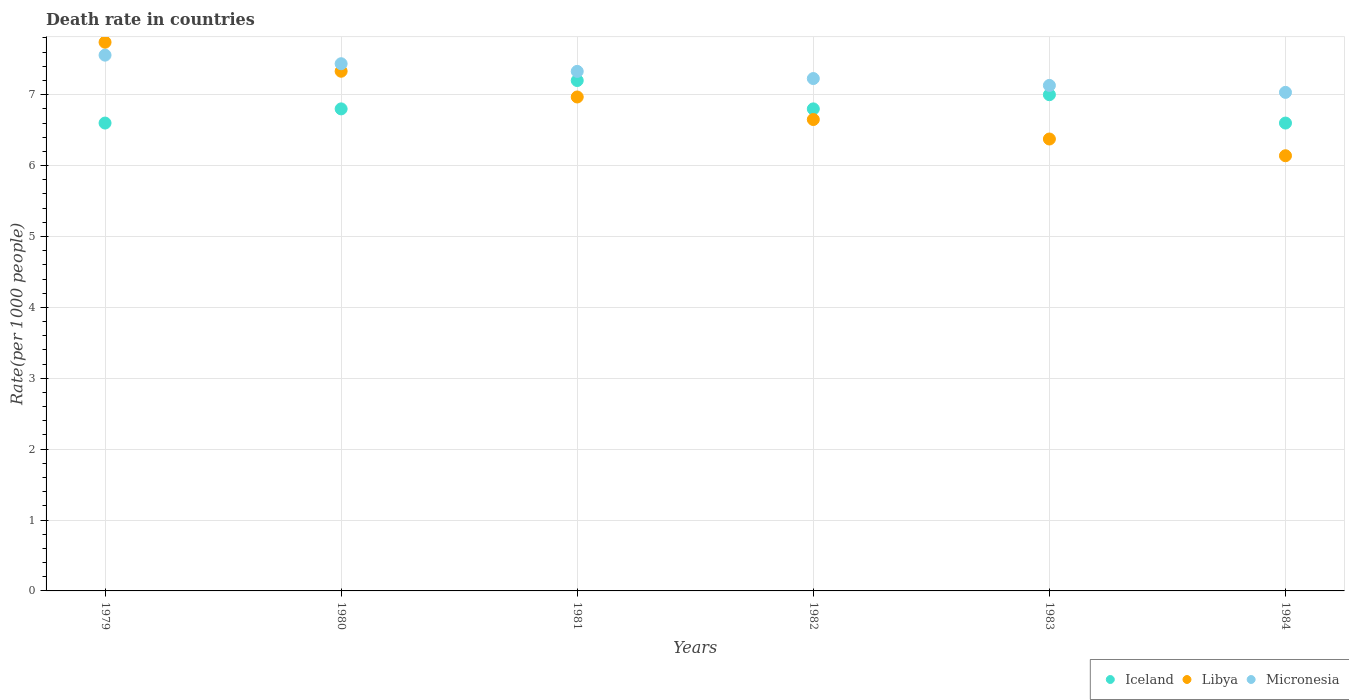How many different coloured dotlines are there?
Your answer should be very brief. 3. Is the number of dotlines equal to the number of legend labels?
Your answer should be very brief. Yes. What is the death rate in Libya in 1983?
Give a very brief answer. 6.38. Across all years, what is the maximum death rate in Libya?
Offer a very short reply. 7.74. Across all years, what is the minimum death rate in Libya?
Offer a very short reply. 6.14. In which year was the death rate in Micronesia maximum?
Your response must be concise. 1979. In which year was the death rate in Iceland minimum?
Make the answer very short. 1979. What is the total death rate in Micronesia in the graph?
Provide a succinct answer. 43.72. What is the difference between the death rate in Libya in 1980 and that in 1984?
Offer a terse response. 1.19. What is the difference between the death rate in Libya in 1983 and the death rate in Micronesia in 1982?
Offer a very short reply. -0.85. What is the average death rate in Micronesia per year?
Provide a succinct answer. 7.29. In the year 1979, what is the difference between the death rate in Micronesia and death rate in Iceland?
Provide a short and direct response. 0.96. In how many years, is the death rate in Libya greater than 1.6?
Give a very brief answer. 6. What is the ratio of the death rate in Iceland in 1981 to that in 1983?
Ensure brevity in your answer.  1.03. Is the death rate in Micronesia in 1980 less than that in 1984?
Provide a short and direct response. No. What is the difference between the highest and the second highest death rate in Libya?
Keep it short and to the point. 0.41. What is the difference between the highest and the lowest death rate in Libya?
Give a very brief answer. 1.6. Is the sum of the death rate in Libya in 1979 and 1983 greater than the maximum death rate in Micronesia across all years?
Ensure brevity in your answer.  Yes. Is it the case that in every year, the sum of the death rate in Micronesia and death rate in Libya  is greater than the death rate in Iceland?
Your answer should be compact. Yes. Does the death rate in Libya monotonically increase over the years?
Your response must be concise. No. Is the death rate in Libya strictly greater than the death rate in Micronesia over the years?
Give a very brief answer. No. Is the death rate in Libya strictly less than the death rate in Micronesia over the years?
Provide a short and direct response. No. Are the values on the major ticks of Y-axis written in scientific E-notation?
Provide a succinct answer. No. Does the graph contain grids?
Provide a short and direct response. Yes. What is the title of the graph?
Keep it short and to the point. Death rate in countries. What is the label or title of the X-axis?
Give a very brief answer. Years. What is the label or title of the Y-axis?
Your response must be concise. Rate(per 1000 people). What is the Rate(per 1000 people) of Libya in 1979?
Offer a very short reply. 7.74. What is the Rate(per 1000 people) in Micronesia in 1979?
Give a very brief answer. 7.56. What is the Rate(per 1000 people) in Iceland in 1980?
Offer a very short reply. 6.8. What is the Rate(per 1000 people) of Libya in 1980?
Make the answer very short. 7.33. What is the Rate(per 1000 people) in Micronesia in 1980?
Your answer should be very brief. 7.44. What is the Rate(per 1000 people) in Libya in 1981?
Provide a succinct answer. 6.97. What is the Rate(per 1000 people) of Micronesia in 1981?
Your response must be concise. 7.33. What is the Rate(per 1000 people) of Libya in 1982?
Provide a succinct answer. 6.65. What is the Rate(per 1000 people) in Micronesia in 1982?
Ensure brevity in your answer.  7.23. What is the Rate(per 1000 people) in Iceland in 1983?
Ensure brevity in your answer.  7. What is the Rate(per 1000 people) of Libya in 1983?
Ensure brevity in your answer.  6.38. What is the Rate(per 1000 people) in Micronesia in 1983?
Keep it short and to the point. 7.13. What is the Rate(per 1000 people) of Libya in 1984?
Your answer should be very brief. 6.14. What is the Rate(per 1000 people) of Micronesia in 1984?
Your response must be concise. 7.03. Across all years, what is the maximum Rate(per 1000 people) of Iceland?
Offer a terse response. 7.2. Across all years, what is the maximum Rate(per 1000 people) in Libya?
Your response must be concise. 7.74. Across all years, what is the maximum Rate(per 1000 people) of Micronesia?
Offer a terse response. 7.56. Across all years, what is the minimum Rate(per 1000 people) in Libya?
Make the answer very short. 6.14. Across all years, what is the minimum Rate(per 1000 people) in Micronesia?
Keep it short and to the point. 7.03. What is the total Rate(per 1000 people) of Libya in the graph?
Give a very brief answer. 41.2. What is the total Rate(per 1000 people) in Micronesia in the graph?
Keep it short and to the point. 43.72. What is the difference between the Rate(per 1000 people) in Libya in 1979 and that in 1980?
Your answer should be compact. 0.41. What is the difference between the Rate(per 1000 people) in Micronesia in 1979 and that in 1980?
Offer a terse response. 0.12. What is the difference between the Rate(per 1000 people) in Iceland in 1979 and that in 1981?
Offer a terse response. -0.6. What is the difference between the Rate(per 1000 people) of Libya in 1979 and that in 1981?
Your response must be concise. 0.77. What is the difference between the Rate(per 1000 people) in Micronesia in 1979 and that in 1981?
Make the answer very short. 0.23. What is the difference between the Rate(per 1000 people) in Libya in 1979 and that in 1982?
Provide a short and direct response. 1.09. What is the difference between the Rate(per 1000 people) of Micronesia in 1979 and that in 1982?
Give a very brief answer. 0.33. What is the difference between the Rate(per 1000 people) in Libya in 1979 and that in 1983?
Offer a very short reply. 1.36. What is the difference between the Rate(per 1000 people) in Micronesia in 1979 and that in 1983?
Ensure brevity in your answer.  0.43. What is the difference between the Rate(per 1000 people) of Libya in 1979 and that in 1984?
Provide a succinct answer. 1.6. What is the difference between the Rate(per 1000 people) of Micronesia in 1979 and that in 1984?
Your answer should be very brief. 0.53. What is the difference between the Rate(per 1000 people) in Iceland in 1980 and that in 1981?
Your answer should be very brief. -0.4. What is the difference between the Rate(per 1000 people) of Libya in 1980 and that in 1981?
Your response must be concise. 0.36. What is the difference between the Rate(per 1000 people) in Micronesia in 1980 and that in 1981?
Make the answer very short. 0.11. What is the difference between the Rate(per 1000 people) of Libya in 1980 and that in 1982?
Offer a very short reply. 0.68. What is the difference between the Rate(per 1000 people) in Micronesia in 1980 and that in 1982?
Ensure brevity in your answer.  0.21. What is the difference between the Rate(per 1000 people) in Libya in 1980 and that in 1983?
Your response must be concise. 0.96. What is the difference between the Rate(per 1000 people) in Micronesia in 1980 and that in 1983?
Provide a succinct answer. 0.31. What is the difference between the Rate(per 1000 people) of Iceland in 1980 and that in 1984?
Offer a very short reply. 0.2. What is the difference between the Rate(per 1000 people) of Libya in 1980 and that in 1984?
Provide a succinct answer. 1.19. What is the difference between the Rate(per 1000 people) of Micronesia in 1980 and that in 1984?
Your answer should be compact. 0.4. What is the difference between the Rate(per 1000 people) of Libya in 1981 and that in 1982?
Provide a succinct answer. 0.32. What is the difference between the Rate(per 1000 people) of Micronesia in 1981 and that in 1982?
Your answer should be very brief. 0.1. What is the difference between the Rate(per 1000 people) in Libya in 1981 and that in 1983?
Give a very brief answer. 0.59. What is the difference between the Rate(per 1000 people) of Micronesia in 1981 and that in 1983?
Your answer should be compact. 0.2. What is the difference between the Rate(per 1000 people) of Libya in 1981 and that in 1984?
Your answer should be compact. 0.83. What is the difference between the Rate(per 1000 people) in Micronesia in 1981 and that in 1984?
Make the answer very short. 0.3. What is the difference between the Rate(per 1000 people) of Libya in 1982 and that in 1983?
Provide a succinct answer. 0.28. What is the difference between the Rate(per 1000 people) of Micronesia in 1982 and that in 1983?
Give a very brief answer. 0.1. What is the difference between the Rate(per 1000 people) in Libya in 1982 and that in 1984?
Make the answer very short. 0.51. What is the difference between the Rate(per 1000 people) in Micronesia in 1982 and that in 1984?
Keep it short and to the point. 0.2. What is the difference between the Rate(per 1000 people) of Iceland in 1983 and that in 1984?
Your response must be concise. 0.4. What is the difference between the Rate(per 1000 people) in Libya in 1983 and that in 1984?
Offer a terse response. 0.24. What is the difference between the Rate(per 1000 people) of Micronesia in 1983 and that in 1984?
Your answer should be very brief. 0.1. What is the difference between the Rate(per 1000 people) of Iceland in 1979 and the Rate(per 1000 people) of Libya in 1980?
Make the answer very short. -0.73. What is the difference between the Rate(per 1000 people) in Iceland in 1979 and the Rate(per 1000 people) in Micronesia in 1980?
Your response must be concise. -0.84. What is the difference between the Rate(per 1000 people) of Libya in 1979 and the Rate(per 1000 people) of Micronesia in 1980?
Offer a very short reply. 0.3. What is the difference between the Rate(per 1000 people) of Iceland in 1979 and the Rate(per 1000 people) of Libya in 1981?
Provide a succinct answer. -0.37. What is the difference between the Rate(per 1000 people) in Iceland in 1979 and the Rate(per 1000 people) in Micronesia in 1981?
Make the answer very short. -0.73. What is the difference between the Rate(per 1000 people) in Libya in 1979 and the Rate(per 1000 people) in Micronesia in 1981?
Make the answer very short. 0.41. What is the difference between the Rate(per 1000 people) of Iceland in 1979 and the Rate(per 1000 people) of Micronesia in 1982?
Your answer should be compact. -0.63. What is the difference between the Rate(per 1000 people) in Libya in 1979 and the Rate(per 1000 people) in Micronesia in 1982?
Your answer should be compact. 0.51. What is the difference between the Rate(per 1000 people) of Iceland in 1979 and the Rate(per 1000 people) of Libya in 1983?
Provide a short and direct response. 0.23. What is the difference between the Rate(per 1000 people) of Iceland in 1979 and the Rate(per 1000 people) of Micronesia in 1983?
Your answer should be compact. -0.53. What is the difference between the Rate(per 1000 people) of Libya in 1979 and the Rate(per 1000 people) of Micronesia in 1983?
Provide a succinct answer. 0.61. What is the difference between the Rate(per 1000 people) of Iceland in 1979 and the Rate(per 1000 people) of Libya in 1984?
Your answer should be compact. 0.46. What is the difference between the Rate(per 1000 people) in Iceland in 1979 and the Rate(per 1000 people) in Micronesia in 1984?
Offer a terse response. -0.43. What is the difference between the Rate(per 1000 people) of Libya in 1979 and the Rate(per 1000 people) of Micronesia in 1984?
Ensure brevity in your answer.  0.71. What is the difference between the Rate(per 1000 people) of Iceland in 1980 and the Rate(per 1000 people) of Libya in 1981?
Make the answer very short. -0.17. What is the difference between the Rate(per 1000 people) in Iceland in 1980 and the Rate(per 1000 people) in Micronesia in 1981?
Provide a short and direct response. -0.53. What is the difference between the Rate(per 1000 people) in Libya in 1980 and the Rate(per 1000 people) in Micronesia in 1981?
Ensure brevity in your answer.  0. What is the difference between the Rate(per 1000 people) of Iceland in 1980 and the Rate(per 1000 people) of Micronesia in 1982?
Your answer should be compact. -0.43. What is the difference between the Rate(per 1000 people) of Libya in 1980 and the Rate(per 1000 people) of Micronesia in 1982?
Offer a very short reply. 0.1. What is the difference between the Rate(per 1000 people) in Iceland in 1980 and the Rate(per 1000 people) in Libya in 1983?
Ensure brevity in your answer.  0.42. What is the difference between the Rate(per 1000 people) of Iceland in 1980 and the Rate(per 1000 people) of Micronesia in 1983?
Your answer should be compact. -0.33. What is the difference between the Rate(per 1000 people) of Iceland in 1980 and the Rate(per 1000 people) of Libya in 1984?
Make the answer very short. 0.66. What is the difference between the Rate(per 1000 people) of Iceland in 1980 and the Rate(per 1000 people) of Micronesia in 1984?
Ensure brevity in your answer.  -0.23. What is the difference between the Rate(per 1000 people) of Libya in 1980 and the Rate(per 1000 people) of Micronesia in 1984?
Your answer should be compact. 0.3. What is the difference between the Rate(per 1000 people) of Iceland in 1981 and the Rate(per 1000 people) of Libya in 1982?
Make the answer very short. 0.55. What is the difference between the Rate(per 1000 people) of Iceland in 1981 and the Rate(per 1000 people) of Micronesia in 1982?
Provide a short and direct response. -0.03. What is the difference between the Rate(per 1000 people) of Libya in 1981 and the Rate(per 1000 people) of Micronesia in 1982?
Give a very brief answer. -0.26. What is the difference between the Rate(per 1000 people) in Iceland in 1981 and the Rate(per 1000 people) in Libya in 1983?
Offer a very short reply. 0.82. What is the difference between the Rate(per 1000 people) in Iceland in 1981 and the Rate(per 1000 people) in Micronesia in 1983?
Give a very brief answer. 0.07. What is the difference between the Rate(per 1000 people) in Libya in 1981 and the Rate(per 1000 people) in Micronesia in 1983?
Keep it short and to the point. -0.16. What is the difference between the Rate(per 1000 people) of Iceland in 1981 and the Rate(per 1000 people) of Libya in 1984?
Ensure brevity in your answer.  1.06. What is the difference between the Rate(per 1000 people) in Iceland in 1981 and the Rate(per 1000 people) in Micronesia in 1984?
Your answer should be compact. 0.17. What is the difference between the Rate(per 1000 people) in Libya in 1981 and the Rate(per 1000 people) in Micronesia in 1984?
Your answer should be compact. -0.07. What is the difference between the Rate(per 1000 people) of Iceland in 1982 and the Rate(per 1000 people) of Libya in 1983?
Ensure brevity in your answer.  0.42. What is the difference between the Rate(per 1000 people) in Iceland in 1982 and the Rate(per 1000 people) in Micronesia in 1983?
Offer a very short reply. -0.33. What is the difference between the Rate(per 1000 people) in Libya in 1982 and the Rate(per 1000 people) in Micronesia in 1983?
Offer a terse response. -0.48. What is the difference between the Rate(per 1000 people) in Iceland in 1982 and the Rate(per 1000 people) in Libya in 1984?
Give a very brief answer. 0.66. What is the difference between the Rate(per 1000 people) of Iceland in 1982 and the Rate(per 1000 people) of Micronesia in 1984?
Provide a short and direct response. -0.23. What is the difference between the Rate(per 1000 people) in Libya in 1982 and the Rate(per 1000 people) in Micronesia in 1984?
Your answer should be very brief. -0.38. What is the difference between the Rate(per 1000 people) in Iceland in 1983 and the Rate(per 1000 people) in Libya in 1984?
Your answer should be very brief. 0.86. What is the difference between the Rate(per 1000 people) in Iceland in 1983 and the Rate(per 1000 people) in Micronesia in 1984?
Provide a succinct answer. -0.03. What is the difference between the Rate(per 1000 people) of Libya in 1983 and the Rate(per 1000 people) of Micronesia in 1984?
Your answer should be very brief. -0.66. What is the average Rate(per 1000 people) of Iceland per year?
Ensure brevity in your answer.  6.83. What is the average Rate(per 1000 people) of Libya per year?
Keep it short and to the point. 6.87. What is the average Rate(per 1000 people) of Micronesia per year?
Your answer should be compact. 7.29. In the year 1979, what is the difference between the Rate(per 1000 people) in Iceland and Rate(per 1000 people) in Libya?
Give a very brief answer. -1.14. In the year 1979, what is the difference between the Rate(per 1000 people) of Iceland and Rate(per 1000 people) of Micronesia?
Provide a succinct answer. -0.96. In the year 1979, what is the difference between the Rate(per 1000 people) of Libya and Rate(per 1000 people) of Micronesia?
Provide a succinct answer. 0.18. In the year 1980, what is the difference between the Rate(per 1000 people) of Iceland and Rate(per 1000 people) of Libya?
Your answer should be compact. -0.53. In the year 1980, what is the difference between the Rate(per 1000 people) of Iceland and Rate(per 1000 people) of Micronesia?
Make the answer very short. -0.64. In the year 1980, what is the difference between the Rate(per 1000 people) in Libya and Rate(per 1000 people) in Micronesia?
Your response must be concise. -0.11. In the year 1981, what is the difference between the Rate(per 1000 people) of Iceland and Rate(per 1000 people) of Libya?
Make the answer very short. 0.23. In the year 1981, what is the difference between the Rate(per 1000 people) in Iceland and Rate(per 1000 people) in Micronesia?
Provide a succinct answer. -0.13. In the year 1981, what is the difference between the Rate(per 1000 people) of Libya and Rate(per 1000 people) of Micronesia?
Provide a succinct answer. -0.36. In the year 1982, what is the difference between the Rate(per 1000 people) of Iceland and Rate(per 1000 people) of Micronesia?
Provide a short and direct response. -0.43. In the year 1982, what is the difference between the Rate(per 1000 people) in Libya and Rate(per 1000 people) in Micronesia?
Keep it short and to the point. -0.58. In the year 1983, what is the difference between the Rate(per 1000 people) of Iceland and Rate(per 1000 people) of Micronesia?
Keep it short and to the point. -0.13. In the year 1983, what is the difference between the Rate(per 1000 people) in Libya and Rate(per 1000 people) in Micronesia?
Offer a terse response. -0.76. In the year 1984, what is the difference between the Rate(per 1000 people) of Iceland and Rate(per 1000 people) of Libya?
Give a very brief answer. 0.46. In the year 1984, what is the difference between the Rate(per 1000 people) in Iceland and Rate(per 1000 people) in Micronesia?
Provide a succinct answer. -0.43. In the year 1984, what is the difference between the Rate(per 1000 people) of Libya and Rate(per 1000 people) of Micronesia?
Your answer should be compact. -0.89. What is the ratio of the Rate(per 1000 people) in Iceland in 1979 to that in 1980?
Your answer should be compact. 0.97. What is the ratio of the Rate(per 1000 people) of Libya in 1979 to that in 1980?
Offer a terse response. 1.06. What is the ratio of the Rate(per 1000 people) in Micronesia in 1979 to that in 1980?
Your response must be concise. 1.02. What is the ratio of the Rate(per 1000 people) in Libya in 1979 to that in 1981?
Offer a very short reply. 1.11. What is the ratio of the Rate(per 1000 people) in Micronesia in 1979 to that in 1981?
Provide a short and direct response. 1.03. What is the ratio of the Rate(per 1000 people) of Iceland in 1979 to that in 1982?
Make the answer very short. 0.97. What is the ratio of the Rate(per 1000 people) in Libya in 1979 to that in 1982?
Keep it short and to the point. 1.16. What is the ratio of the Rate(per 1000 people) of Micronesia in 1979 to that in 1982?
Offer a very short reply. 1.05. What is the ratio of the Rate(per 1000 people) in Iceland in 1979 to that in 1983?
Keep it short and to the point. 0.94. What is the ratio of the Rate(per 1000 people) of Libya in 1979 to that in 1983?
Give a very brief answer. 1.21. What is the ratio of the Rate(per 1000 people) in Micronesia in 1979 to that in 1983?
Offer a terse response. 1.06. What is the ratio of the Rate(per 1000 people) of Libya in 1979 to that in 1984?
Your response must be concise. 1.26. What is the ratio of the Rate(per 1000 people) of Micronesia in 1979 to that in 1984?
Make the answer very short. 1.07. What is the ratio of the Rate(per 1000 people) of Iceland in 1980 to that in 1981?
Offer a terse response. 0.94. What is the ratio of the Rate(per 1000 people) of Libya in 1980 to that in 1981?
Make the answer very short. 1.05. What is the ratio of the Rate(per 1000 people) in Micronesia in 1980 to that in 1981?
Offer a terse response. 1.01. What is the ratio of the Rate(per 1000 people) of Libya in 1980 to that in 1982?
Provide a short and direct response. 1.1. What is the ratio of the Rate(per 1000 people) in Micronesia in 1980 to that in 1982?
Your answer should be compact. 1.03. What is the ratio of the Rate(per 1000 people) of Iceland in 1980 to that in 1983?
Offer a very short reply. 0.97. What is the ratio of the Rate(per 1000 people) of Libya in 1980 to that in 1983?
Offer a terse response. 1.15. What is the ratio of the Rate(per 1000 people) in Micronesia in 1980 to that in 1983?
Keep it short and to the point. 1.04. What is the ratio of the Rate(per 1000 people) in Iceland in 1980 to that in 1984?
Provide a succinct answer. 1.03. What is the ratio of the Rate(per 1000 people) of Libya in 1980 to that in 1984?
Offer a very short reply. 1.19. What is the ratio of the Rate(per 1000 people) in Micronesia in 1980 to that in 1984?
Provide a succinct answer. 1.06. What is the ratio of the Rate(per 1000 people) of Iceland in 1981 to that in 1982?
Provide a succinct answer. 1.06. What is the ratio of the Rate(per 1000 people) of Libya in 1981 to that in 1982?
Give a very brief answer. 1.05. What is the ratio of the Rate(per 1000 people) of Micronesia in 1981 to that in 1982?
Offer a very short reply. 1.01. What is the ratio of the Rate(per 1000 people) of Iceland in 1981 to that in 1983?
Provide a short and direct response. 1.03. What is the ratio of the Rate(per 1000 people) in Libya in 1981 to that in 1983?
Make the answer very short. 1.09. What is the ratio of the Rate(per 1000 people) in Micronesia in 1981 to that in 1983?
Your answer should be compact. 1.03. What is the ratio of the Rate(per 1000 people) in Iceland in 1981 to that in 1984?
Make the answer very short. 1.09. What is the ratio of the Rate(per 1000 people) of Libya in 1981 to that in 1984?
Provide a succinct answer. 1.14. What is the ratio of the Rate(per 1000 people) of Micronesia in 1981 to that in 1984?
Provide a succinct answer. 1.04. What is the ratio of the Rate(per 1000 people) of Iceland in 1982 to that in 1983?
Offer a very short reply. 0.97. What is the ratio of the Rate(per 1000 people) of Libya in 1982 to that in 1983?
Ensure brevity in your answer.  1.04. What is the ratio of the Rate(per 1000 people) of Micronesia in 1982 to that in 1983?
Your answer should be very brief. 1.01. What is the ratio of the Rate(per 1000 people) of Iceland in 1982 to that in 1984?
Keep it short and to the point. 1.03. What is the ratio of the Rate(per 1000 people) of Libya in 1982 to that in 1984?
Provide a succinct answer. 1.08. What is the ratio of the Rate(per 1000 people) in Micronesia in 1982 to that in 1984?
Provide a short and direct response. 1.03. What is the ratio of the Rate(per 1000 people) in Iceland in 1983 to that in 1984?
Your answer should be compact. 1.06. What is the ratio of the Rate(per 1000 people) of Libya in 1983 to that in 1984?
Offer a very short reply. 1.04. What is the ratio of the Rate(per 1000 people) of Micronesia in 1983 to that in 1984?
Keep it short and to the point. 1.01. What is the difference between the highest and the second highest Rate(per 1000 people) of Libya?
Ensure brevity in your answer.  0.41. What is the difference between the highest and the second highest Rate(per 1000 people) of Micronesia?
Provide a short and direct response. 0.12. What is the difference between the highest and the lowest Rate(per 1000 people) of Libya?
Your response must be concise. 1.6. What is the difference between the highest and the lowest Rate(per 1000 people) in Micronesia?
Offer a very short reply. 0.53. 